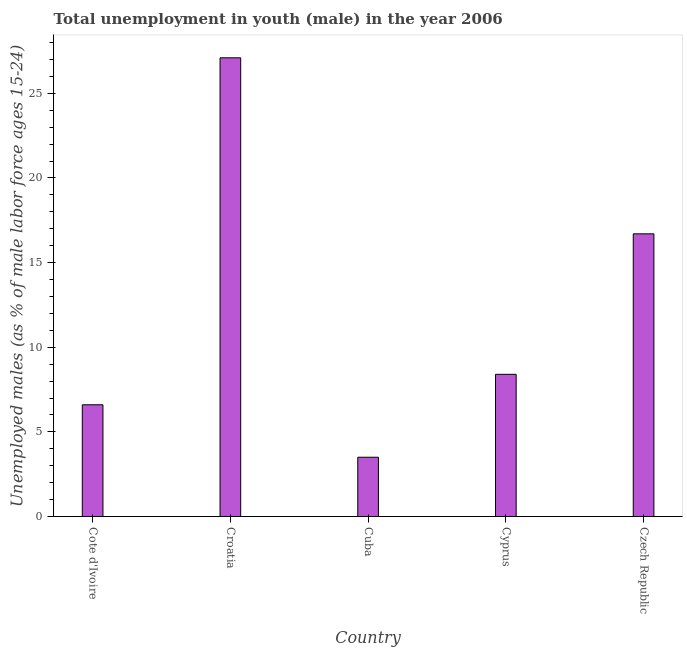Does the graph contain any zero values?
Keep it short and to the point. No. What is the title of the graph?
Offer a terse response. Total unemployment in youth (male) in the year 2006. What is the label or title of the X-axis?
Make the answer very short. Country. What is the label or title of the Y-axis?
Your answer should be compact. Unemployed males (as % of male labor force ages 15-24). What is the unemployed male youth population in Croatia?
Your answer should be very brief. 27.1. Across all countries, what is the maximum unemployed male youth population?
Give a very brief answer. 27.1. Across all countries, what is the minimum unemployed male youth population?
Give a very brief answer. 3.5. In which country was the unemployed male youth population maximum?
Keep it short and to the point. Croatia. In which country was the unemployed male youth population minimum?
Keep it short and to the point. Cuba. What is the sum of the unemployed male youth population?
Give a very brief answer. 62.3. What is the average unemployed male youth population per country?
Your answer should be very brief. 12.46. What is the median unemployed male youth population?
Ensure brevity in your answer.  8.4. What is the ratio of the unemployed male youth population in Cote d'Ivoire to that in Cyprus?
Ensure brevity in your answer.  0.79. Is the difference between the unemployed male youth population in Cote d'Ivoire and Cyprus greater than the difference between any two countries?
Provide a short and direct response. No. What is the difference between the highest and the second highest unemployed male youth population?
Your answer should be very brief. 10.4. What is the difference between the highest and the lowest unemployed male youth population?
Your answer should be compact. 23.6. Are all the bars in the graph horizontal?
Give a very brief answer. No. What is the difference between two consecutive major ticks on the Y-axis?
Your answer should be very brief. 5. What is the Unemployed males (as % of male labor force ages 15-24) in Cote d'Ivoire?
Give a very brief answer. 6.6. What is the Unemployed males (as % of male labor force ages 15-24) of Croatia?
Your response must be concise. 27.1. What is the Unemployed males (as % of male labor force ages 15-24) in Cyprus?
Your response must be concise. 8.4. What is the Unemployed males (as % of male labor force ages 15-24) in Czech Republic?
Offer a very short reply. 16.7. What is the difference between the Unemployed males (as % of male labor force ages 15-24) in Cote d'Ivoire and Croatia?
Your answer should be very brief. -20.5. What is the difference between the Unemployed males (as % of male labor force ages 15-24) in Cote d'Ivoire and Czech Republic?
Keep it short and to the point. -10.1. What is the difference between the Unemployed males (as % of male labor force ages 15-24) in Croatia and Cuba?
Give a very brief answer. 23.6. What is the difference between the Unemployed males (as % of male labor force ages 15-24) in Croatia and Cyprus?
Offer a very short reply. 18.7. What is the difference between the Unemployed males (as % of male labor force ages 15-24) in Croatia and Czech Republic?
Your answer should be compact. 10.4. What is the ratio of the Unemployed males (as % of male labor force ages 15-24) in Cote d'Ivoire to that in Croatia?
Your answer should be compact. 0.24. What is the ratio of the Unemployed males (as % of male labor force ages 15-24) in Cote d'Ivoire to that in Cuba?
Your answer should be compact. 1.89. What is the ratio of the Unemployed males (as % of male labor force ages 15-24) in Cote d'Ivoire to that in Cyprus?
Give a very brief answer. 0.79. What is the ratio of the Unemployed males (as % of male labor force ages 15-24) in Cote d'Ivoire to that in Czech Republic?
Keep it short and to the point. 0.4. What is the ratio of the Unemployed males (as % of male labor force ages 15-24) in Croatia to that in Cuba?
Ensure brevity in your answer.  7.74. What is the ratio of the Unemployed males (as % of male labor force ages 15-24) in Croatia to that in Cyprus?
Provide a short and direct response. 3.23. What is the ratio of the Unemployed males (as % of male labor force ages 15-24) in Croatia to that in Czech Republic?
Keep it short and to the point. 1.62. What is the ratio of the Unemployed males (as % of male labor force ages 15-24) in Cuba to that in Cyprus?
Offer a very short reply. 0.42. What is the ratio of the Unemployed males (as % of male labor force ages 15-24) in Cuba to that in Czech Republic?
Provide a short and direct response. 0.21. What is the ratio of the Unemployed males (as % of male labor force ages 15-24) in Cyprus to that in Czech Republic?
Ensure brevity in your answer.  0.5. 